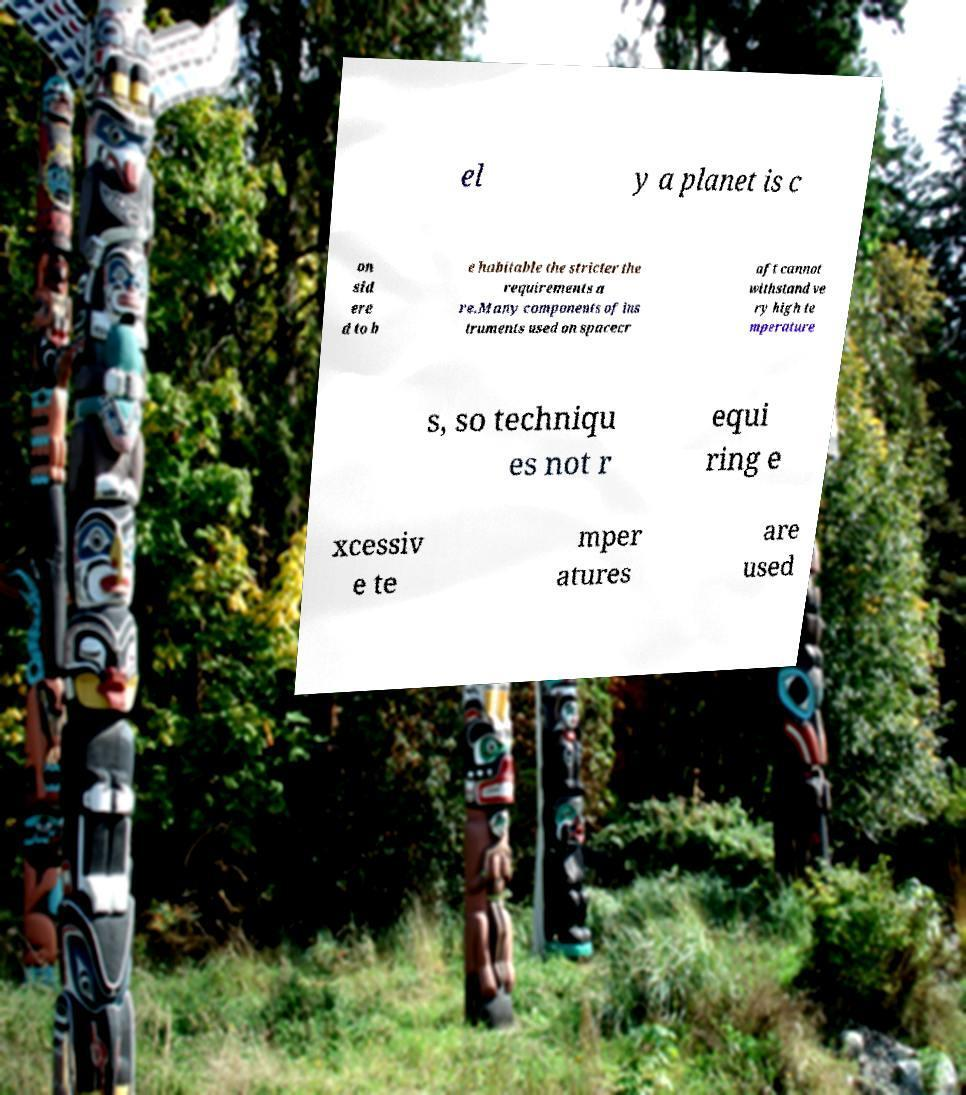Could you extract and type out the text from this image? el y a planet is c on sid ere d to b e habitable the stricter the requirements a re.Many components of ins truments used on spacecr aft cannot withstand ve ry high te mperature s, so techniqu es not r equi ring e xcessiv e te mper atures are used 